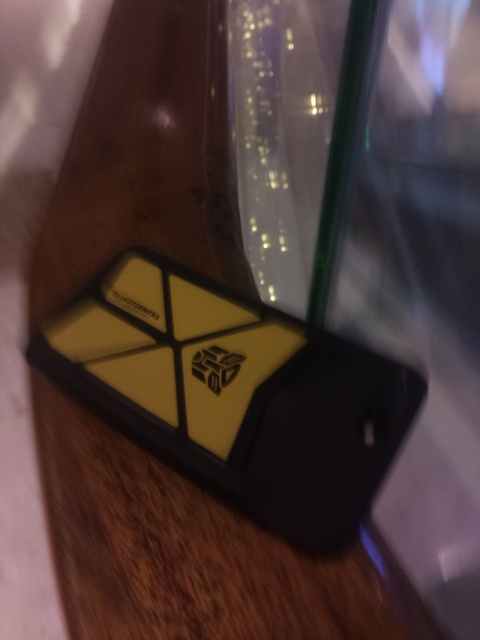Are the content in the image blurred?
A. No
B. Yes
Answer with the option's letter from the given choices directly.
 B. 